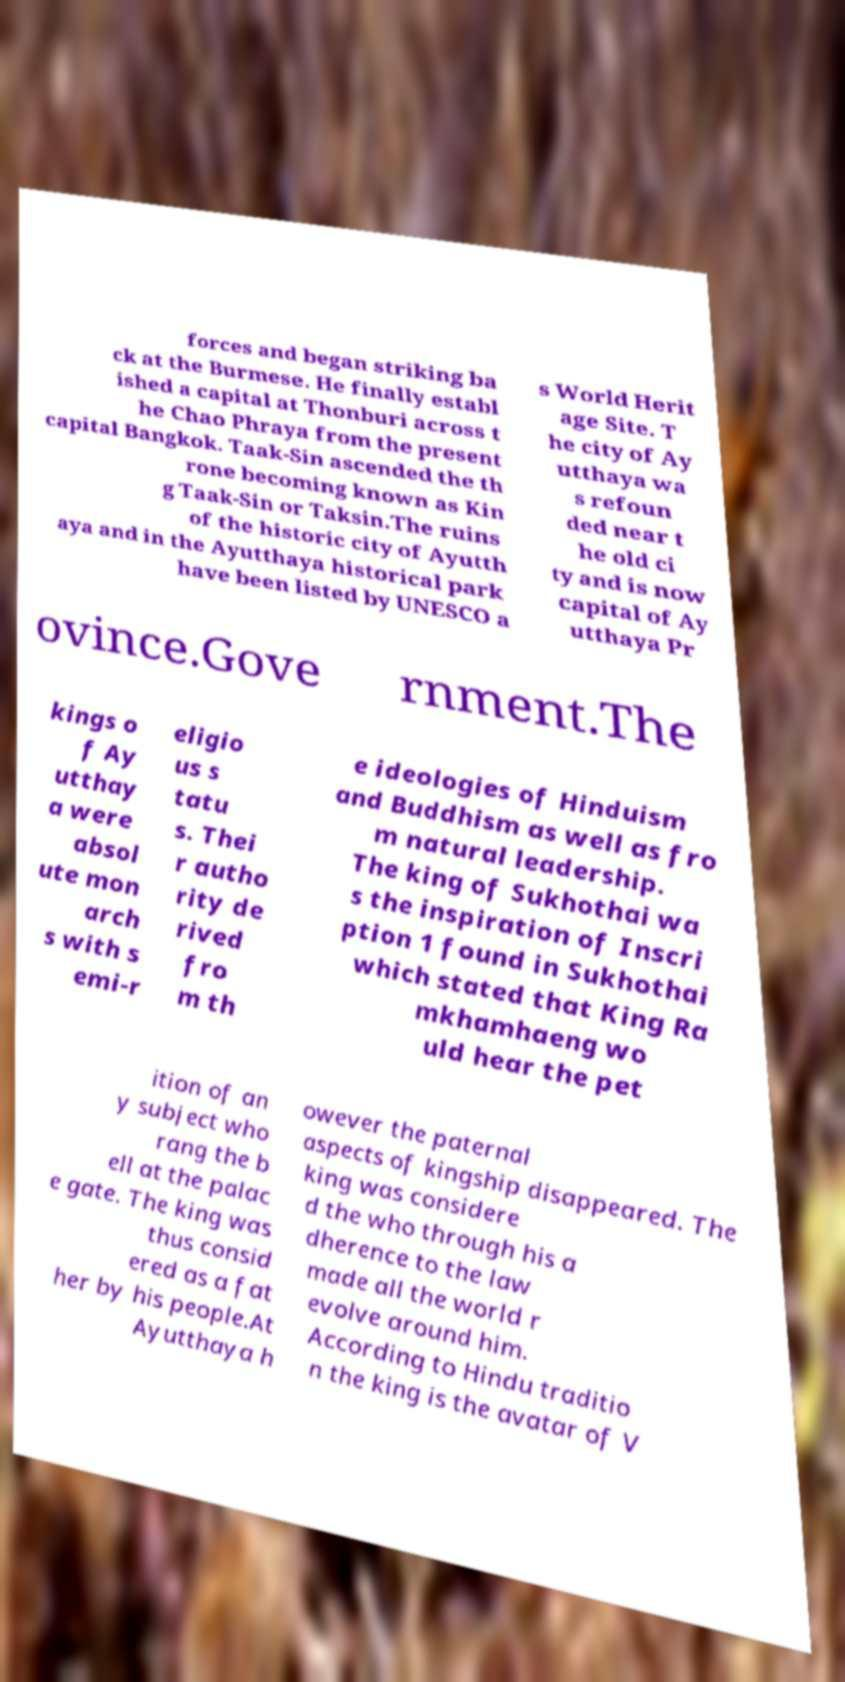There's text embedded in this image that I need extracted. Can you transcribe it verbatim? forces and began striking ba ck at the Burmese. He finally establ ished a capital at Thonburi across t he Chao Phraya from the present capital Bangkok. Taak-Sin ascended the th rone becoming known as Kin g Taak-Sin or Taksin.The ruins of the historic city of Ayutth aya and in the Ayutthaya historical park have been listed by UNESCO a s World Herit age Site. T he city of Ay utthaya wa s refoun ded near t he old ci ty and is now capital of Ay utthaya Pr ovince.Gove rnment.The kings o f Ay utthay a were absol ute mon arch s with s emi-r eligio us s tatu s. Thei r autho rity de rived fro m th e ideologies of Hinduism and Buddhism as well as fro m natural leadership. The king of Sukhothai wa s the inspiration of Inscri ption 1 found in Sukhothai which stated that King Ra mkhamhaeng wo uld hear the pet ition of an y subject who rang the b ell at the palac e gate. The king was thus consid ered as a fat her by his people.At Ayutthaya h owever the paternal aspects of kingship disappeared. The king was considere d the who through his a dherence to the law made all the world r evolve around him. According to Hindu traditio n the king is the avatar of V 